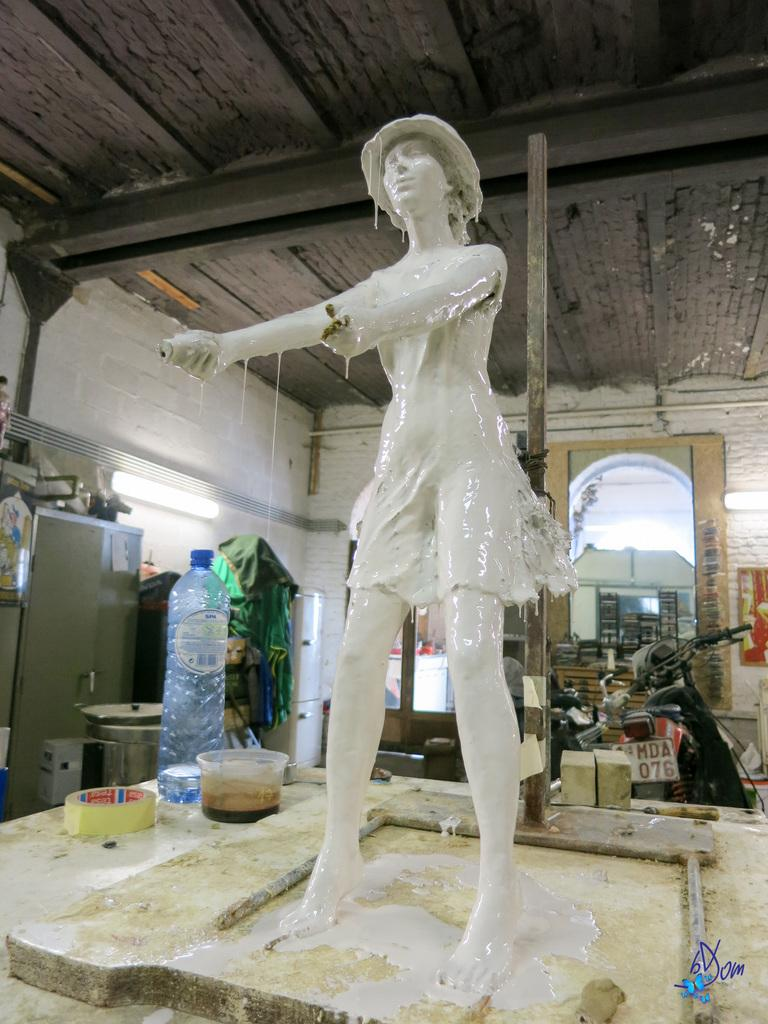What is the main subject in the image? There is a sculpture in the image. What other objects can be seen in the image? There is a bottle and a bowl in the image. Can you describe the background of the image? There is a wall, a bike, and other unspecified things in the background of the image. There are also lights visible. How many geese are sitting on the chair in the image? There are no geese or chairs present in the image. 